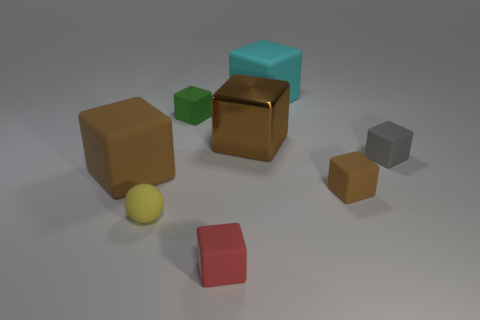There is a object that is to the right of the tiny brown block to the right of the tiny matte cube that is in front of the small rubber sphere; what is its material? The object to the right of the tiny brown block, which is itself to the right of the tiny matte cube in front of the small rubber sphere, appears to be a small green cube with a matte finish. Therefore, its material is not rubber but appears to be similar to the matte cube, suggesting it too could likely be made of a hard plastic or a similar non-rubber material. 